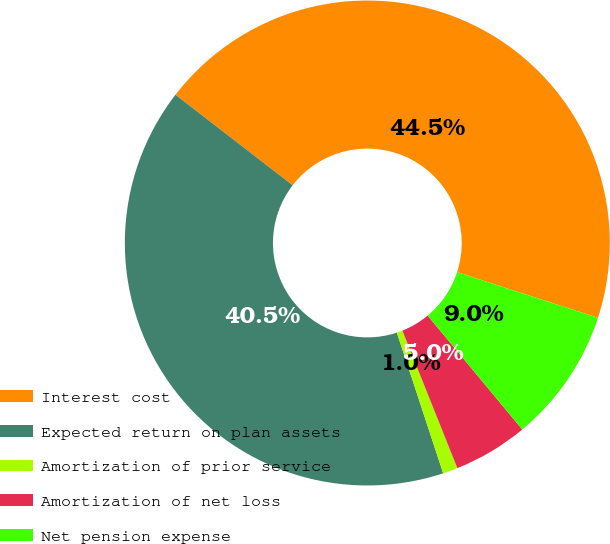<chart> <loc_0><loc_0><loc_500><loc_500><pie_chart><fcel>Interest cost<fcel>Expected return on plan assets<fcel>Amortization of prior service<fcel>Amortization of net loss<fcel>Net pension expense<nl><fcel>44.52%<fcel>40.53%<fcel>0.99%<fcel>4.98%<fcel>8.97%<nl></chart> 